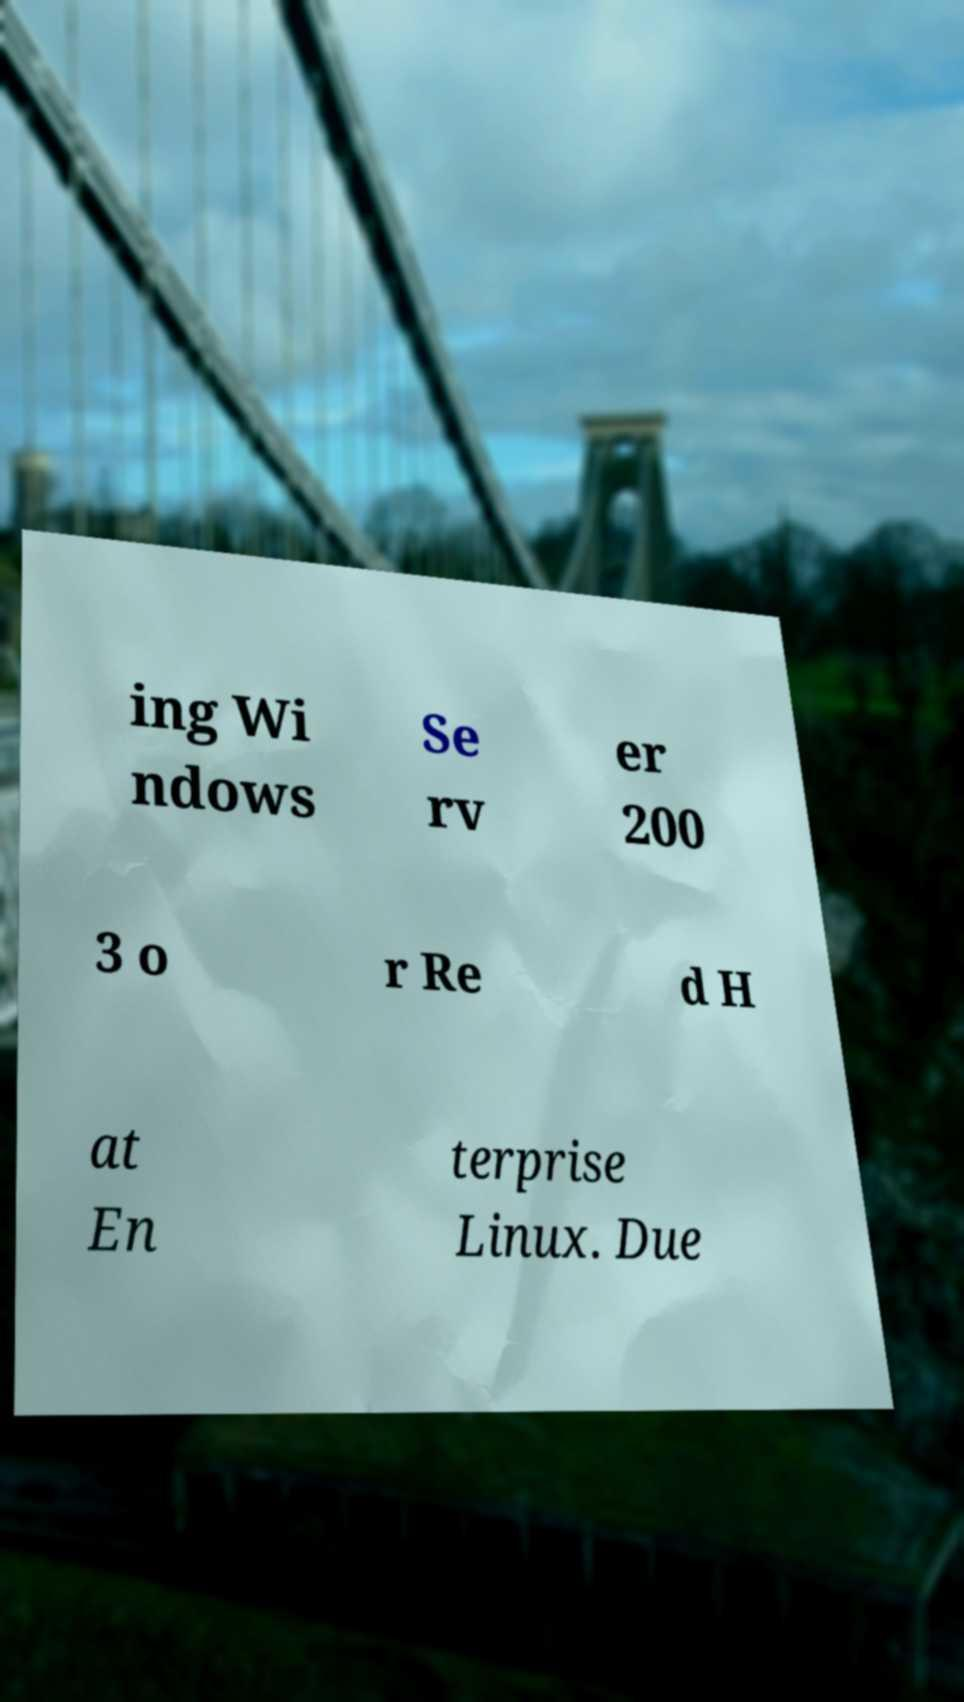For documentation purposes, I need the text within this image transcribed. Could you provide that? ing Wi ndows Se rv er 200 3 o r Re d H at En terprise Linux. Due 